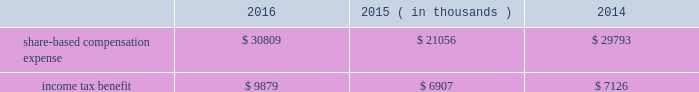2000 non-employee director stock option plan ( the 201cdirector stock option plan 201d ) , and the global payments inc .
2011 incentive plan ( the 201c2011 plan 201d ) ( collectively , the 201cplans 201d ) .
We made no further grants under the 2000 plan after the 2005 plan was effective , and the director stock option plan expired by its terms on february 1 , 2011 .
We will make no future grants under the 2000 plan , the 2005 plan or the director stock option plan .
The 2011 plan permits grants of equity to employees , officers , directors and consultants .
A total of 14.0 million shares of our common stock was reserved and made available for issuance pursuant to awards granted under the 2011 plan .
The table summarizes share-based compensation expense and the related income tax benefit recognized for our share-based awards and stock options ( in thousands ) : 2016 2015 2014 ( in thousands ) .
We grant various share-based awards pursuant to the plans under what we refer to as our 201clong-term incentive plan . 201d the awards are held in escrow and released upon the grantee 2019s satisfaction of conditions of the award certificate .
Restricted stock restricted stock awards vest over a period of time , provided , however , that if the grantee is not employed by us on the vesting date , the shares are forfeited .
Restricted shares cannot be sold or transferred until they have vested .
Restricted stock granted before fiscal 2015 vests in equal installments on each of the first four anniversaries of the grant date .
Restricted stock granted during fiscal 2015 and thereafter either vest in equal installments on each of the first three anniversaries of the grant date or cliff vest at the end of a three-year service period .
The grant date fair value of restricted stock , which is based on the quoted market value of our common stock at the closing of the award date , is recognized as share-based compensation expense on a straight-line basis over the vesting period .
Performance units certain of our executives have been granted performance units under our long-term incentive plan .
Performance units are performance-based restricted stock units that , after a performance period , convert into common shares , which may be restricted .
The number of shares is dependent upon the achievement of certain performance measures during the performance period .
The target number of performance units and any market-based performance measures ( 201cat threshold , 201d 201ctarget , 201d and 201cmaximum 201d ) are set by the compensation committee of our board of directors .
Performance units are converted only after the compensation committee certifies performance based on pre-established goals .
The performance units granted to certain executives in fiscal 2014 were based on a one-year performance period .
After the compensation committee certified the performance results , 25% ( 25 % ) of the performance units converted to unrestricted shares .
The remaining 75% ( 75 % ) converted to restricted shares that vest in equal installments on each of the first three anniversaries of the conversion date .
The performance units granted to certain executives during fiscal 2015 and fiscal 2016 were based on a three-year performance period .
After the compensation committee certifies the performance results for the three-year period , performance units earned will convert into unrestricted common stock .
The compensation committee may set a range of possible performance-based outcomes for performance units .
Depending on the achievement of the performance measures , the grantee may earn up to 200% ( 200 % ) of the target number of shares .
For awards with only performance conditions , we recognize compensation expense on a straight-line basis over the performance period using the grant date fair value of the award , which is based on the number of shares expected to be earned according to the level of achievement of performance goals .
If the number of shares expected to be earned were to change at any time during the performance period , we would make a cumulative adjustment to share-based compensation expense based on the revised number of shares expected to be earned .
Global payments inc .
| 2016 form 10-k annual report 2013 83 .
How much percent did the income tax benefit increase from 2014 to 2016? 
Rationale: the tax benefit increased 38.6% , one can find this by subtracting 2016 by 2014 tax benefits . then taking the answer and dividing it by 2014 tax benefits .
Computations: ((9879 - 7126) / 7126)
Answer: 0.38633. 